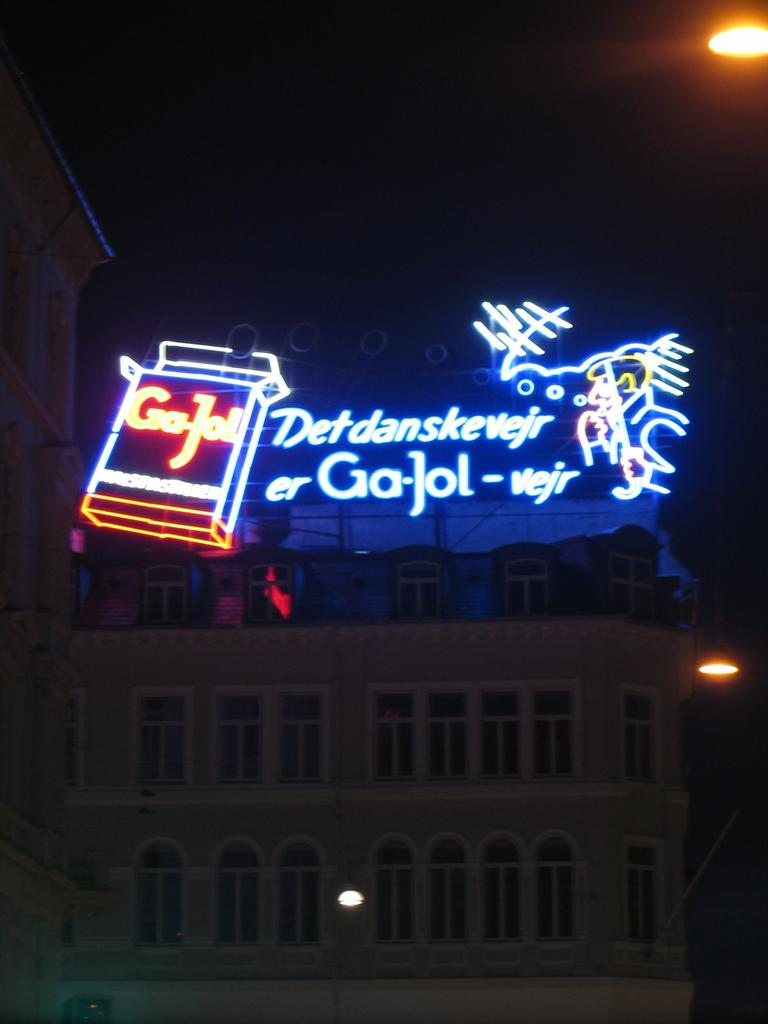What type of structure is present in the image? There is a building in the image. What can be seen illuminated in the image? There are lights visible in the image. What electronic device is present in the image? There is a digital board in the image. How would you describe the overall lighting in the image? The background of the image is dark. What type of wood is used to construct the quiver in the image? There is no quiver present in the image, so it is not possible to determine the type of wood used for its construction. 